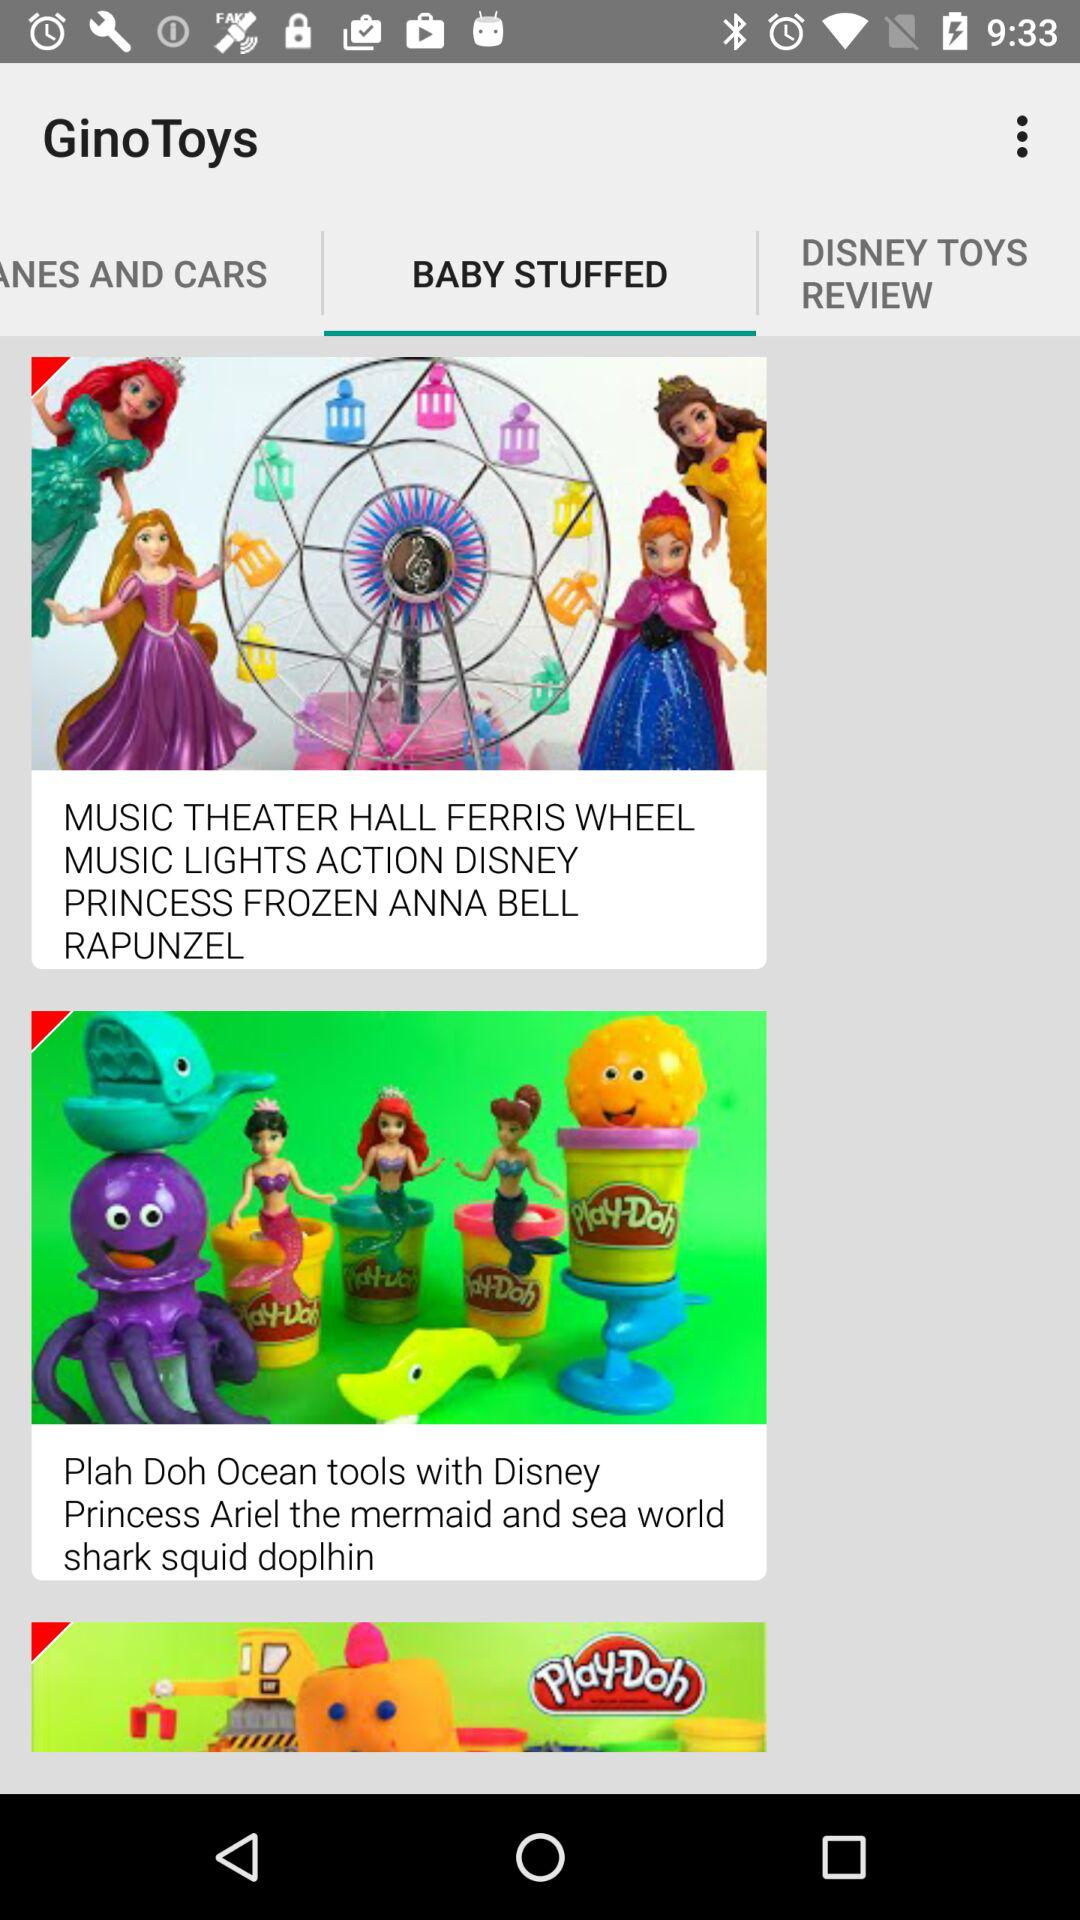What is the name of the application? The application name is "GinoToys". 